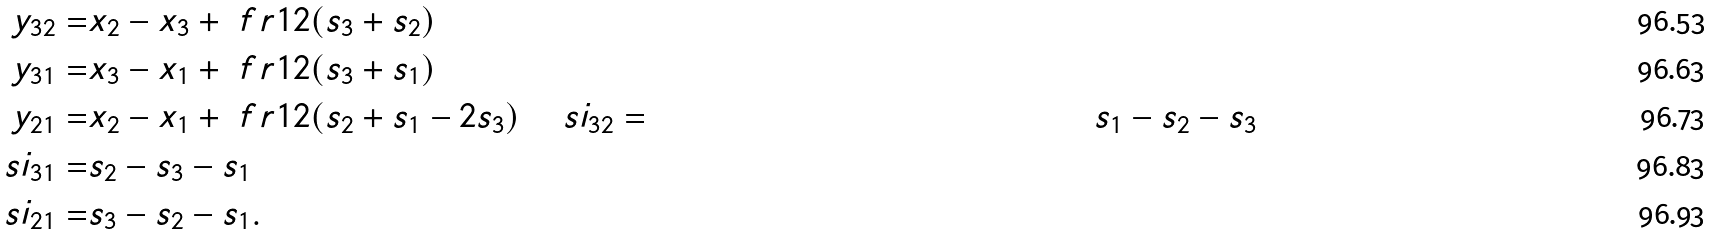<formula> <loc_0><loc_0><loc_500><loc_500>y _ { 3 2 } = & x _ { 2 } - x _ { 3 } + \ f r { 1 } { 2 } ( s _ { 3 } + s _ { 2 } ) \\ y _ { 3 1 } = & x _ { 3 } - x _ { 1 } + \ f r { 1 } { 2 } ( s _ { 3 } + s _ { 1 } ) \\ y _ { 2 1 } = & x _ { 2 } - x _ { 1 } + \ f r { 1 } { 2 } ( s _ { 2 } + s _ { 1 } - 2 s _ { 3 } ) \quad \ s i _ { 3 2 } = & s _ { 1 } - s _ { 2 } - s _ { 3 } \\ \ s i _ { 3 1 } = & s _ { 2 } - s _ { 3 } - s _ { 1 } \\ \ s i _ { 2 1 } = & s _ { 3 } - s _ { 2 } - s _ { 1 } .</formula> 